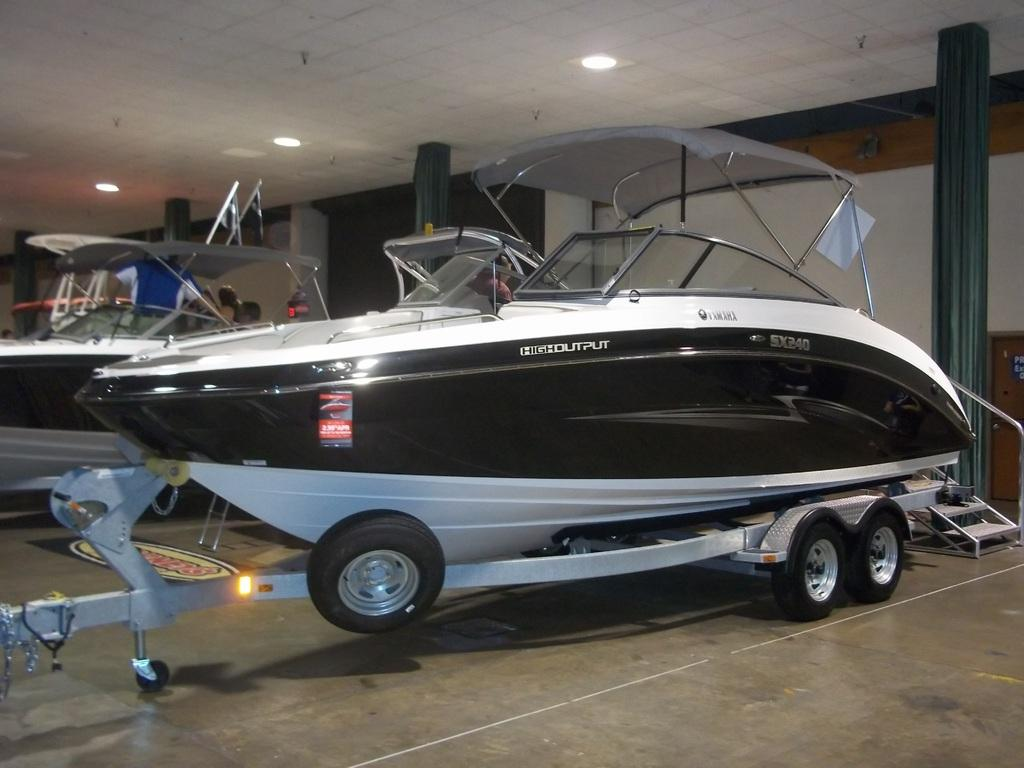What objects are on the floor in the image? There are vehicles on the floor in the image. What can be seen in the background of the image? Lights and pillars are visible in the background of the image. What type of structure is present in the background of the image? There is a wall in the background of the image. What type of leather material is visible on the vehicles in the image? There is no mention of leather material in the image; it is not possible to determine the type of material used for the vehicles. 